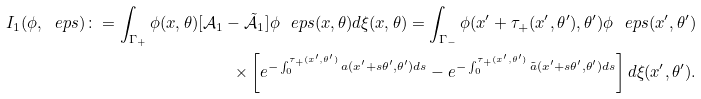Convert formula to latex. <formula><loc_0><loc_0><loc_500><loc_500>I _ { 1 } ( \phi , \ e p s ) \colon = \int _ { \Gamma _ { + } } \phi ( x , \theta ) [ \mathcal { A } _ { 1 } - \tilde { \mathcal { A } } _ { 1 } ] \phi _ { \ } e p s ( x , \theta ) d \xi ( x , \theta ) = \int _ { \Gamma _ { - } } \phi ( x ^ { \prime } + \tau _ { + } ( x ^ { \prime } , \theta ^ { \prime } ) , \theta ^ { \prime } ) \phi _ { \ } e p s ( x ^ { \prime } , \theta ^ { \prime } ) \\ \times \left [ e ^ { - \int _ { 0 } ^ { \tau _ { + } ( x ^ { \prime } , \theta ^ { \prime } ) } a ( x ^ { \prime } + s \theta ^ { \prime } , \theta ^ { \prime } ) d s } - e ^ { - \int _ { 0 } ^ { \tau _ { + } ( x ^ { \prime } , \theta ^ { \prime } ) } \tilde { a } ( x ^ { \prime } + s \theta ^ { \prime } , \theta ^ { \prime } ) d s } \right ] d \xi ( x ^ { \prime } , \theta ^ { \prime } ) .</formula> 